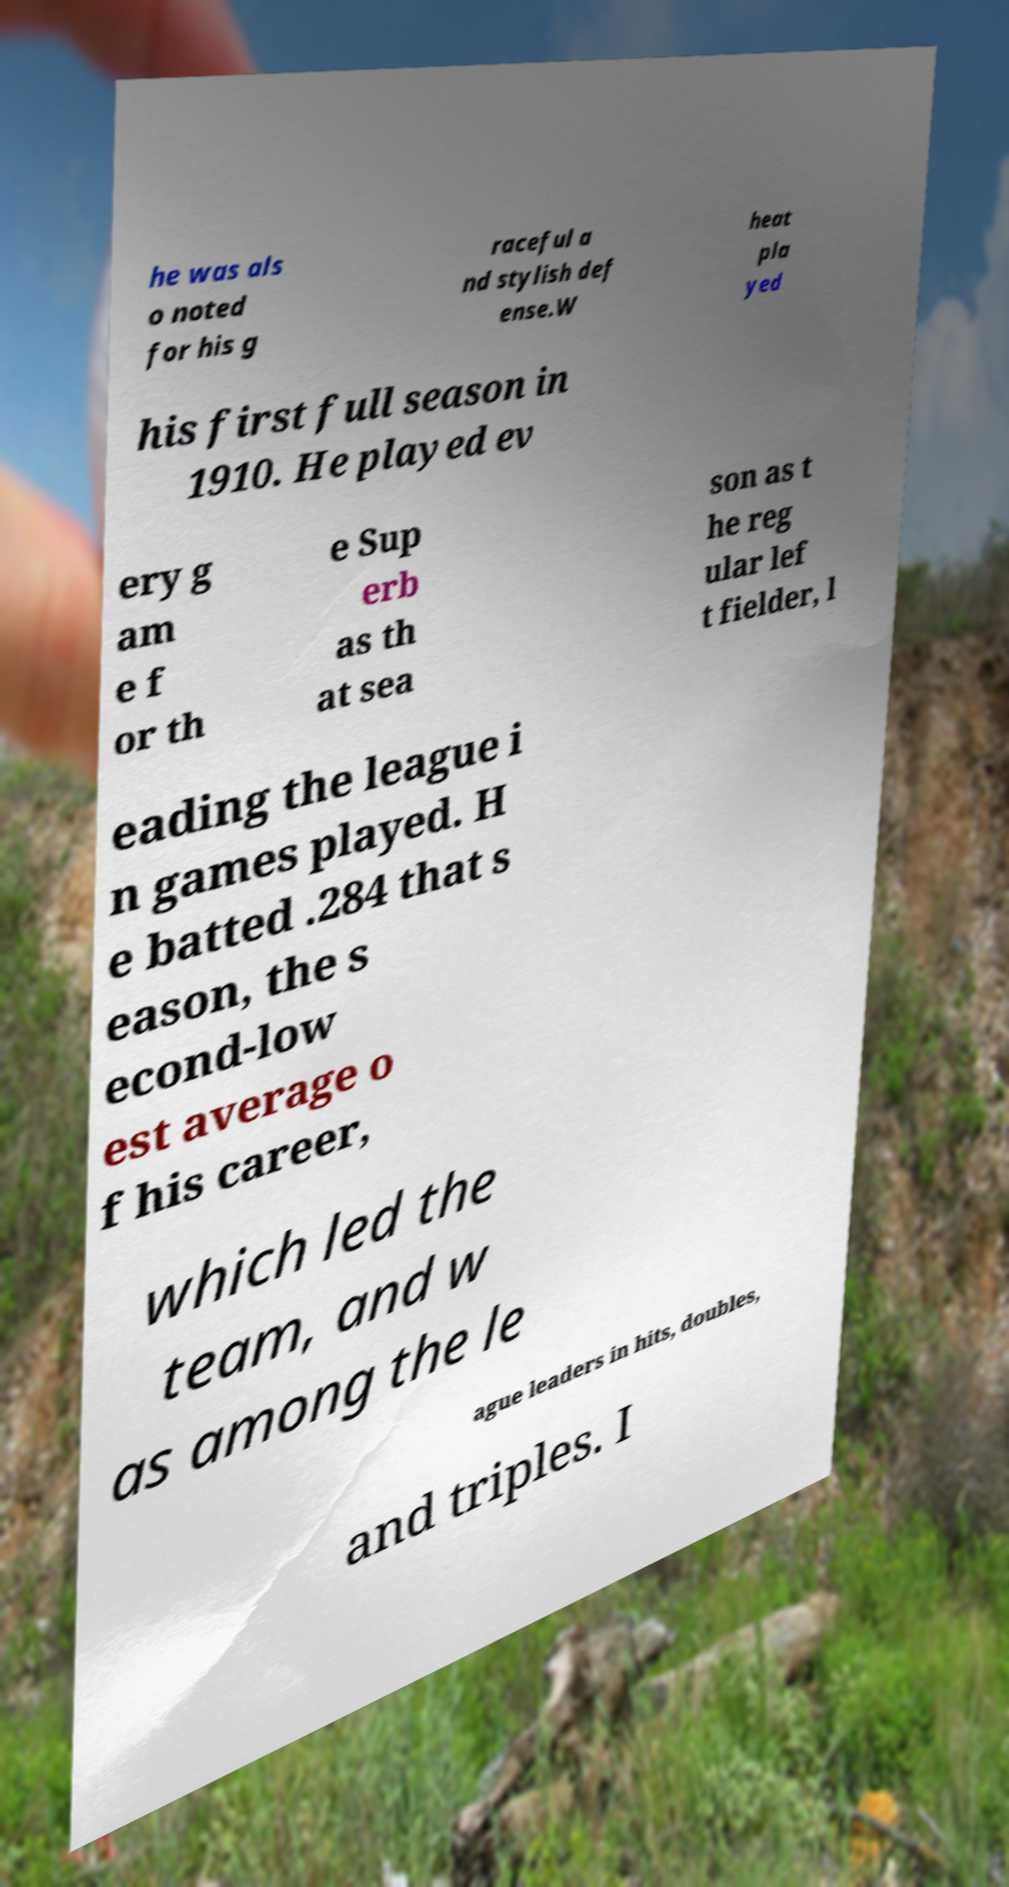Could you assist in decoding the text presented in this image and type it out clearly? he was als o noted for his g raceful a nd stylish def ense.W heat pla yed his first full season in 1910. He played ev ery g am e f or th e Sup erb as th at sea son as t he reg ular lef t fielder, l eading the league i n games played. H e batted .284 that s eason, the s econd-low est average o f his career, which led the team, and w as among the le ague leaders in hits, doubles, and triples. I 